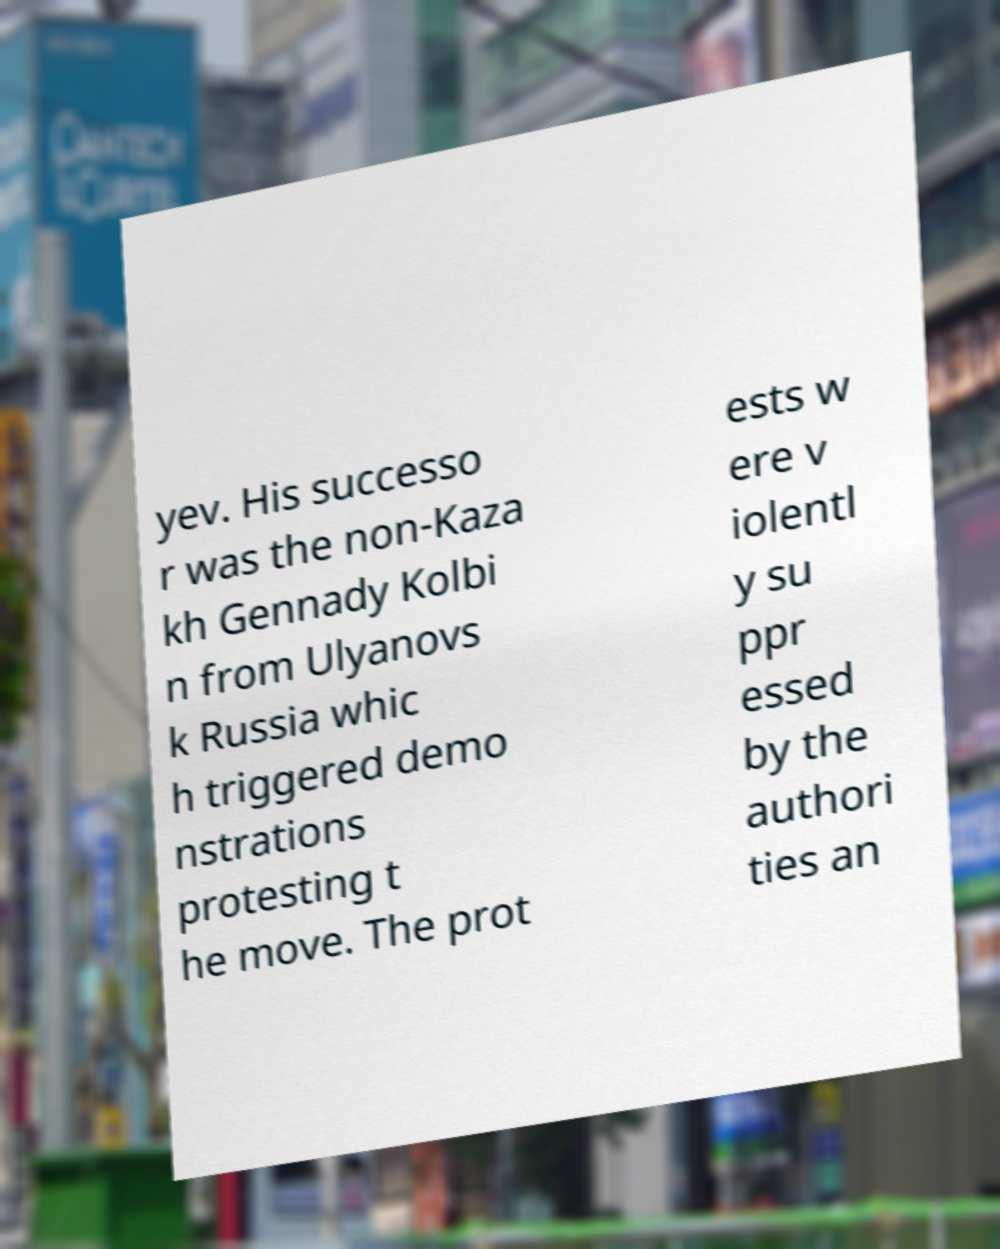What messages or text are displayed in this image? I need them in a readable, typed format. yev. His successo r was the non-Kaza kh Gennady Kolbi n from Ulyanovs k Russia whic h triggered demo nstrations protesting t he move. The prot ests w ere v iolentl y su ppr essed by the authori ties an 